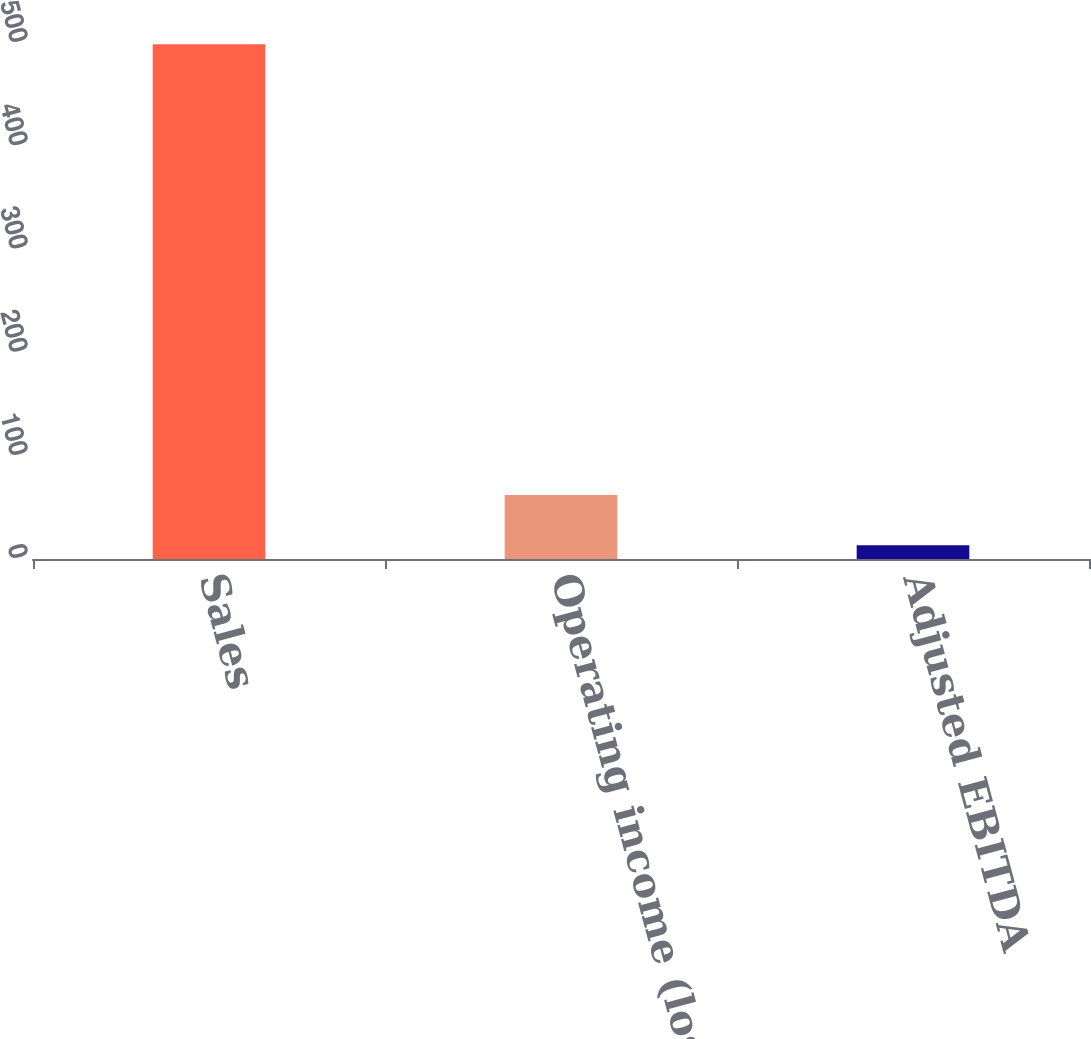Convert chart to OTSL. <chart><loc_0><loc_0><loc_500><loc_500><bar_chart><fcel>Sales<fcel>Operating income (loss)<fcel>Adjusted EBITDA<nl><fcel>498.8<fcel>61.94<fcel>13.4<nl></chart> 